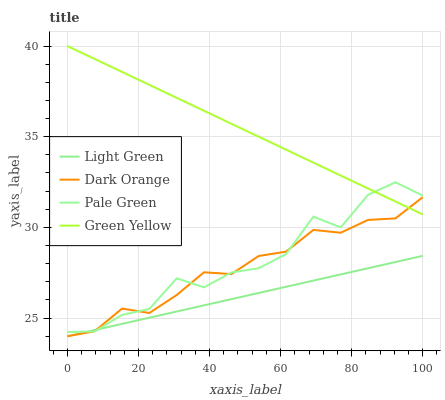Does Light Green have the minimum area under the curve?
Answer yes or no. Yes. Does Green Yellow have the maximum area under the curve?
Answer yes or no. Yes. Does Pale Green have the minimum area under the curve?
Answer yes or no. No. Does Pale Green have the maximum area under the curve?
Answer yes or no. No. Is Light Green the smoothest?
Answer yes or no. Yes. Is Pale Green the roughest?
Answer yes or no. Yes. Is Green Yellow the smoothest?
Answer yes or no. No. Is Green Yellow the roughest?
Answer yes or no. No. Does Dark Orange have the lowest value?
Answer yes or no. Yes. Does Pale Green have the lowest value?
Answer yes or no. No. Does Green Yellow have the highest value?
Answer yes or no. Yes. Does Pale Green have the highest value?
Answer yes or no. No. Is Light Green less than Green Yellow?
Answer yes or no. Yes. Is Green Yellow greater than Light Green?
Answer yes or no. Yes. Does Pale Green intersect Light Green?
Answer yes or no. Yes. Is Pale Green less than Light Green?
Answer yes or no. No. Is Pale Green greater than Light Green?
Answer yes or no. No. Does Light Green intersect Green Yellow?
Answer yes or no. No. 